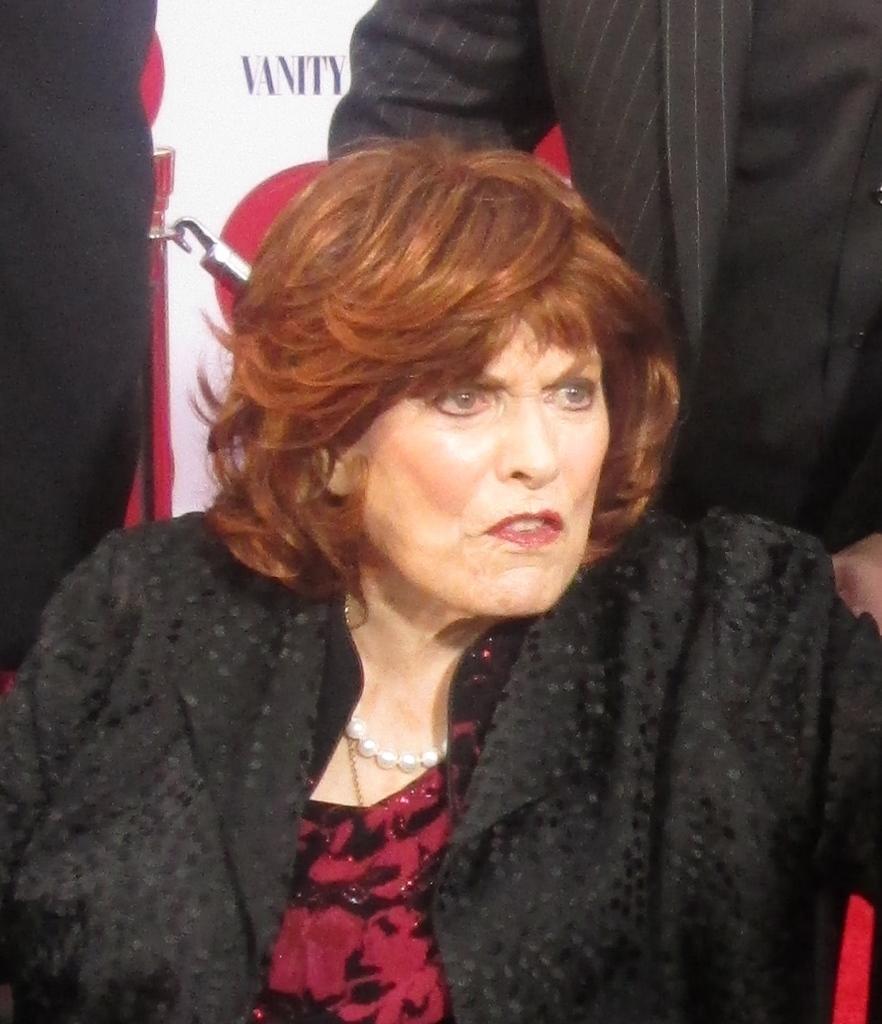Can you describe this image briefly? In this image I can see a woman is wearing maroon and black dress. Back I can see few people and white and red color banner. 